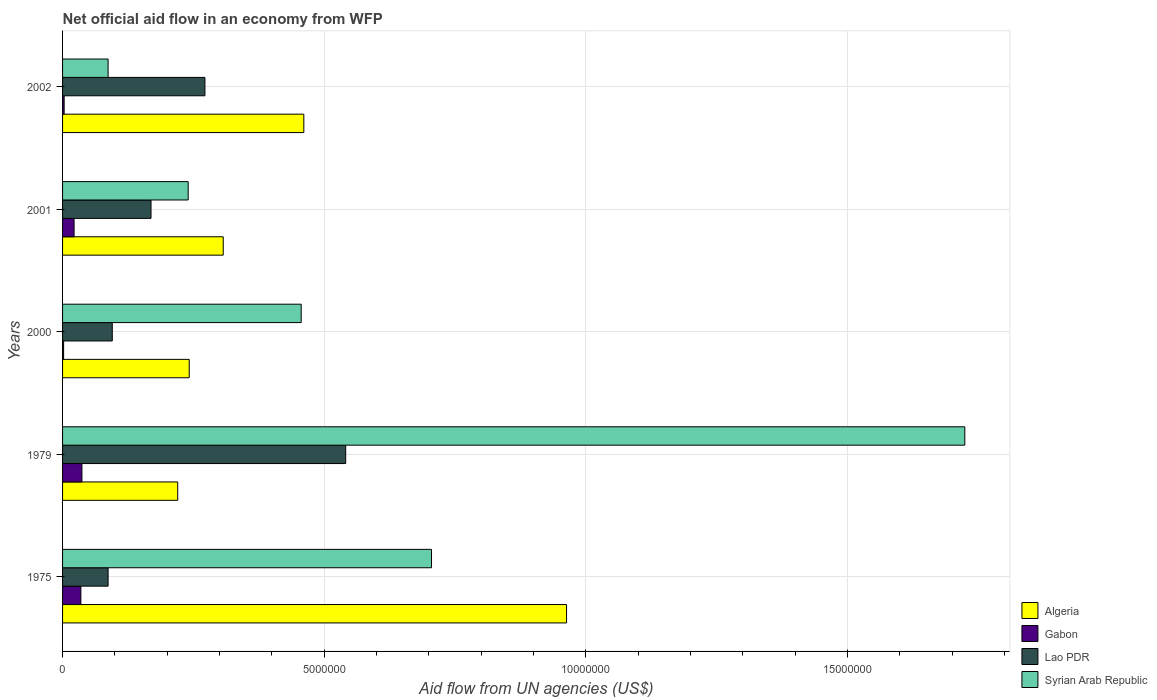How many different coloured bars are there?
Ensure brevity in your answer.  4. Are the number of bars on each tick of the Y-axis equal?
Give a very brief answer. Yes. What is the net official aid flow in Algeria in 1979?
Your answer should be very brief. 2.20e+06. Across all years, what is the maximum net official aid flow in Syrian Arab Republic?
Give a very brief answer. 1.72e+07. Across all years, what is the minimum net official aid flow in Algeria?
Make the answer very short. 2.20e+06. In which year was the net official aid flow in Algeria maximum?
Provide a short and direct response. 1975. In which year was the net official aid flow in Lao PDR minimum?
Your response must be concise. 1975. What is the total net official aid flow in Lao PDR in the graph?
Keep it short and to the point. 1.16e+07. What is the difference between the net official aid flow in Lao PDR in 1979 and that in 2002?
Give a very brief answer. 2.69e+06. What is the difference between the net official aid flow in Gabon in 1979 and the net official aid flow in Syrian Arab Republic in 2001?
Provide a short and direct response. -2.03e+06. What is the average net official aid flow in Algeria per year?
Your answer should be compact. 4.39e+06. In the year 2000, what is the difference between the net official aid flow in Syrian Arab Republic and net official aid flow in Lao PDR?
Give a very brief answer. 3.61e+06. In how many years, is the net official aid flow in Lao PDR greater than 11000000 US$?
Offer a very short reply. 0. What is the ratio of the net official aid flow in Gabon in 1979 to that in 2002?
Offer a very short reply. 12.33. What is the difference between the highest and the lowest net official aid flow in Gabon?
Provide a succinct answer. 3.50e+05. Is it the case that in every year, the sum of the net official aid flow in Gabon and net official aid flow in Syrian Arab Republic is greater than the sum of net official aid flow in Algeria and net official aid flow in Lao PDR?
Offer a very short reply. No. What does the 1st bar from the top in 2002 represents?
Offer a terse response. Syrian Arab Republic. What does the 1st bar from the bottom in 1979 represents?
Your response must be concise. Algeria. Are all the bars in the graph horizontal?
Your answer should be very brief. Yes. Does the graph contain any zero values?
Make the answer very short. No. Does the graph contain grids?
Provide a succinct answer. Yes. What is the title of the graph?
Your response must be concise. Net official aid flow in an economy from WFP. Does "Luxembourg" appear as one of the legend labels in the graph?
Provide a short and direct response. No. What is the label or title of the X-axis?
Make the answer very short. Aid flow from UN agencies (US$). What is the label or title of the Y-axis?
Give a very brief answer. Years. What is the Aid flow from UN agencies (US$) of Algeria in 1975?
Your response must be concise. 9.63e+06. What is the Aid flow from UN agencies (US$) in Gabon in 1975?
Offer a very short reply. 3.50e+05. What is the Aid flow from UN agencies (US$) in Lao PDR in 1975?
Make the answer very short. 8.70e+05. What is the Aid flow from UN agencies (US$) of Syrian Arab Republic in 1975?
Provide a succinct answer. 7.05e+06. What is the Aid flow from UN agencies (US$) of Algeria in 1979?
Offer a terse response. 2.20e+06. What is the Aid flow from UN agencies (US$) of Gabon in 1979?
Provide a short and direct response. 3.70e+05. What is the Aid flow from UN agencies (US$) of Lao PDR in 1979?
Offer a very short reply. 5.41e+06. What is the Aid flow from UN agencies (US$) in Syrian Arab Republic in 1979?
Keep it short and to the point. 1.72e+07. What is the Aid flow from UN agencies (US$) in Algeria in 2000?
Offer a very short reply. 2.42e+06. What is the Aid flow from UN agencies (US$) in Lao PDR in 2000?
Provide a succinct answer. 9.50e+05. What is the Aid flow from UN agencies (US$) of Syrian Arab Republic in 2000?
Offer a very short reply. 4.56e+06. What is the Aid flow from UN agencies (US$) in Algeria in 2001?
Provide a succinct answer. 3.07e+06. What is the Aid flow from UN agencies (US$) of Gabon in 2001?
Give a very brief answer. 2.20e+05. What is the Aid flow from UN agencies (US$) of Lao PDR in 2001?
Make the answer very short. 1.69e+06. What is the Aid flow from UN agencies (US$) of Syrian Arab Republic in 2001?
Make the answer very short. 2.40e+06. What is the Aid flow from UN agencies (US$) in Algeria in 2002?
Make the answer very short. 4.61e+06. What is the Aid flow from UN agencies (US$) in Gabon in 2002?
Your answer should be very brief. 3.00e+04. What is the Aid flow from UN agencies (US$) in Lao PDR in 2002?
Offer a terse response. 2.72e+06. What is the Aid flow from UN agencies (US$) of Syrian Arab Republic in 2002?
Your answer should be very brief. 8.70e+05. Across all years, what is the maximum Aid flow from UN agencies (US$) of Algeria?
Keep it short and to the point. 9.63e+06. Across all years, what is the maximum Aid flow from UN agencies (US$) in Lao PDR?
Ensure brevity in your answer.  5.41e+06. Across all years, what is the maximum Aid flow from UN agencies (US$) in Syrian Arab Republic?
Make the answer very short. 1.72e+07. Across all years, what is the minimum Aid flow from UN agencies (US$) in Algeria?
Offer a terse response. 2.20e+06. Across all years, what is the minimum Aid flow from UN agencies (US$) in Gabon?
Give a very brief answer. 2.00e+04. Across all years, what is the minimum Aid flow from UN agencies (US$) of Lao PDR?
Your answer should be very brief. 8.70e+05. Across all years, what is the minimum Aid flow from UN agencies (US$) in Syrian Arab Republic?
Your response must be concise. 8.70e+05. What is the total Aid flow from UN agencies (US$) of Algeria in the graph?
Provide a short and direct response. 2.19e+07. What is the total Aid flow from UN agencies (US$) of Gabon in the graph?
Provide a short and direct response. 9.90e+05. What is the total Aid flow from UN agencies (US$) of Lao PDR in the graph?
Keep it short and to the point. 1.16e+07. What is the total Aid flow from UN agencies (US$) in Syrian Arab Republic in the graph?
Your answer should be very brief. 3.21e+07. What is the difference between the Aid flow from UN agencies (US$) in Algeria in 1975 and that in 1979?
Provide a succinct answer. 7.43e+06. What is the difference between the Aid flow from UN agencies (US$) of Lao PDR in 1975 and that in 1979?
Offer a terse response. -4.54e+06. What is the difference between the Aid flow from UN agencies (US$) of Syrian Arab Republic in 1975 and that in 1979?
Provide a short and direct response. -1.02e+07. What is the difference between the Aid flow from UN agencies (US$) in Algeria in 1975 and that in 2000?
Your answer should be compact. 7.21e+06. What is the difference between the Aid flow from UN agencies (US$) in Gabon in 1975 and that in 2000?
Provide a succinct answer. 3.30e+05. What is the difference between the Aid flow from UN agencies (US$) in Lao PDR in 1975 and that in 2000?
Make the answer very short. -8.00e+04. What is the difference between the Aid flow from UN agencies (US$) in Syrian Arab Republic in 1975 and that in 2000?
Keep it short and to the point. 2.49e+06. What is the difference between the Aid flow from UN agencies (US$) in Algeria in 1975 and that in 2001?
Provide a short and direct response. 6.56e+06. What is the difference between the Aid flow from UN agencies (US$) of Lao PDR in 1975 and that in 2001?
Offer a very short reply. -8.20e+05. What is the difference between the Aid flow from UN agencies (US$) in Syrian Arab Republic in 1975 and that in 2001?
Give a very brief answer. 4.65e+06. What is the difference between the Aid flow from UN agencies (US$) of Algeria in 1975 and that in 2002?
Your answer should be very brief. 5.02e+06. What is the difference between the Aid flow from UN agencies (US$) of Lao PDR in 1975 and that in 2002?
Ensure brevity in your answer.  -1.85e+06. What is the difference between the Aid flow from UN agencies (US$) in Syrian Arab Republic in 1975 and that in 2002?
Make the answer very short. 6.18e+06. What is the difference between the Aid flow from UN agencies (US$) in Algeria in 1979 and that in 2000?
Ensure brevity in your answer.  -2.20e+05. What is the difference between the Aid flow from UN agencies (US$) in Lao PDR in 1979 and that in 2000?
Give a very brief answer. 4.46e+06. What is the difference between the Aid flow from UN agencies (US$) in Syrian Arab Republic in 1979 and that in 2000?
Provide a short and direct response. 1.27e+07. What is the difference between the Aid flow from UN agencies (US$) of Algeria in 1979 and that in 2001?
Your response must be concise. -8.70e+05. What is the difference between the Aid flow from UN agencies (US$) in Gabon in 1979 and that in 2001?
Provide a short and direct response. 1.50e+05. What is the difference between the Aid flow from UN agencies (US$) of Lao PDR in 1979 and that in 2001?
Keep it short and to the point. 3.72e+06. What is the difference between the Aid flow from UN agencies (US$) of Syrian Arab Republic in 1979 and that in 2001?
Provide a short and direct response. 1.48e+07. What is the difference between the Aid flow from UN agencies (US$) of Algeria in 1979 and that in 2002?
Ensure brevity in your answer.  -2.41e+06. What is the difference between the Aid flow from UN agencies (US$) in Lao PDR in 1979 and that in 2002?
Give a very brief answer. 2.69e+06. What is the difference between the Aid flow from UN agencies (US$) in Syrian Arab Republic in 1979 and that in 2002?
Give a very brief answer. 1.64e+07. What is the difference between the Aid flow from UN agencies (US$) in Algeria in 2000 and that in 2001?
Your answer should be very brief. -6.50e+05. What is the difference between the Aid flow from UN agencies (US$) of Gabon in 2000 and that in 2001?
Keep it short and to the point. -2.00e+05. What is the difference between the Aid flow from UN agencies (US$) in Lao PDR in 2000 and that in 2001?
Ensure brevity in your answer.  -7.40e+05. What is the difference between the Aid flow from UN agencies (US$) of Syrian Arab Republic in 2000 and that in 2001?
Your answer should be very brief. 2.16e+06. What is the difference between the Aid flow from UN agencies (US$) in Algeria in 2000 and that in 2002?
Make the answer very short. -2.19e+06. What is the difference between the Aid flow from UN agencies (US$) of Gabon in 2000 and that in 2002?
Your response must be concise. -10000. What is the difference between the Aid flow from UN agencies (US$) of Lao PDR in 2000 and that in 2002?
Your answer should be very brief. -1.77e+06. What is the difference between the Aid flow from UN agencies (US$) of Syrian Arab Republic in 2000 and that in 2002?
Offer a terse response. 3.69e+06. What is the difference between the Aid flow from UN agencies (US$) in Algeria in 2001 and that in 2002?
Give a very brief answer. -1.54e+06. What is the difference between the Aid flow from UN agencies (US$) in Lao PDR in 2001 and that in 2002?
Your answer should be compact. -1.03e+06. What is the difference between the Aid flow from UN agencies (US$) of Syrian Arab Republic in 2001 and that in 2002?
Offer a terse response. 1.53e+06. What is the difference between the Aid flow from UN agencies (US$) of Algeria in 1975 and the Aid flow from UN agencies (US$) of Gabon in 1979?
Your answer should be compact. 9.26e+06. What is the difference between the Aid flow from UN agencies (US$) of Algeria in 1975 and the Aid flow from UN agencies (US$) of Lao PDR in 1979?
Your response must be concise. 4.22e+06. What is the difference between the Aid flow from UN agencies (US$) of Algeria in 1975 and the Aid flow from UN agencies (US$) of Syrian Arab Republic in 1979?
Your answer should be compact. -7.61e+06. What is the difference between the Aid flow from UN agencies (US$) in Gabon in 1975 and the Aid flow from UN agencies (US$) in Lao PDR in 1979?
Keep it short and to the point. -5.06e+06. What is the difference between the Aid flow from UN agencies (US$) in Gabon in 1975 and the Aid flow from UN agencies (US$) in Syrian Arab Republic in 1979?
Your answer should be compact. -1.69e+07. What is the difference between the Aid flow from UN agencies (US$) of Lao PDR in 1975 and the Aid flow from UN agencies (US$) of Syrian Arab Republic in 1979?
Your answer should be very brief. -1.64e+07. What is the difference between the Aid flow from UN agencies (US$) of Algeria in 1975 and the Aid flow from UN agencies (US$) of Gabon in 2000?
Your answer should be compact. 9.61e+06. What is the difference between the Aid flow from UN agencies (US$) of Algeria in 1975 and the Aid flow from UN agencies (US$) of Lao PDR in 2000?
Your answer should be very brief. 8.68e+06. What is the difference between the Aid flow from UN agencies (US$) of Algeria in 1975 and the Aid flow from UN agencies (US$) of Syrian Arab Republic in 2000?
Give a very brief answer. 5.07e+06. What is the difference between the Aid flow from UN agencies (US$) in Gabon in 1975 and the Aid flow from UN agencies (US$) in Lao PDR in 2000?
Offer a terse response. -6.00e+05. What is the difference between the Aid flow from UN agencies (US$) of Gabon in 1975 and the Aid flow from UN agencies (US$) of Syrian Arab Republic in 2000?
Offer a terse response. -4.21e+06. What is the difference between the Aid flow from UN agencies (US$) of Lao PDR in 1975 and the Aid flow from UN agencies (US$) of Syrian Arab Republic in 2000?
Offer a terse response. -3.69e+06. What is the difference between the Aid flow from UN agencies (US$) of Algeria in 1975 and the Aid flow from UN agencies (US$) of Gabon in 2001?
Your answer should be very brief. 9.41e+06. What is the difference between the Aid flow from UN agencies (US$) of Algeria in 1975 and the Aid flow from UN agencies (US$) of Lao PDR in 2001?
Offer a terse response. 7.94e+06. What is the difference between the Aid flow from UN agencies (US$) in Algeria in 1975 and the Aid flow from UN agencies (US$) in Syrian Arab Republic in 2001?
Give a very brief answer. 7.23e+06. What is the difference between the Aid flow from UN agencies (US$) in Gabon in 1975 and the Aid flow from UN agencies (US$) in Lao PDR in 2001?
Offer a very short reply. -1.34e+06. What is the difference between the Aid flow from UN agencies (US$) in Gabon in 1975 and the Aid flow from UN agencies (US$) in Syrian Arab Republic in 2001?
Provide a succinct answer. -2.05e+06. What is the difference between the Aid flow from UN agencies (US$) of Lao PDR in 1975 and the Aid flow from UN agencies (US$) of Syrian Arab Republic in 2001?
Provide a succinct answer. -1.53e+06. What is the difference between the Aid flow from UN agencies (US$) in Algeria in 1975 and the Aid flow from UN agencies (US$) in Gabon in 2002?
Your response must be concise. 9.60e+06. What is the difference between the Aid flow from UN agencies (US$) in Algeria in 1975 and the Aid flow from UN agencies (US$) in Lao PDR in 2002?
Make the answer very short. 6.91e+06. What is the difference between the Aid flow from UN agencies (US$) of Algeria in 1975 and the Aid flow from UN agencies (US$) of Syrian Arab Republic in 2002?
Provide a succinct answer. 8.76e+06. What is the difference between the Aid flow from UN agencies (US$) in Gabon in 1975 and the Aid flow from UN agencies (US$) in Lao PDR in 2002?
Your answer should be very brief. -2.37e+06. What is the difference between the Aid flow from UN agencies (US$) of Gabon in 1975 and the Aid flow from UN agencies (US$) of Syrian Arab Republic in 2002?
Your response must be concise. -5.20e+05. What is the difference between the Aid flow from UN agencies (US$) of Algeria in 1979 and the Aid flow from UN agencies (US$) of Gabon in 2000?
Keep it short and to the point. 2.18e+06. What is the difference between the Aid flow from UN agencies (US$) of Algeria in 1979 and the Aid flow from UN agencies (US$) of Lao PDR in 2000?
Your answer should be compact. 1.25e+06. What is the difference between the Aid flow from UN agencies (US$) of Algeria in 1979 and the Aid flow from UN agencies (US$) of Syrian Arab Republic in 2000?
Make the answer very short. -2.36e+06. What is the difference between the Aid flow from UN agencies (US$) in Gabon in 1979 and the Aid flow from UN agencies (US$) in Lao PDR in 2000?
Provide a succinct answer. -5.80e+05. What is the difference between the Aid flow from UN agencies (US$) in Gabon in 1979 and the Aid flow from UN agencies (US$) in Syrian Arab Republic in 2000?
Offer a very short reply. -4.19e+06. What is the difference between the Aid flow from UN agencies (US$) in Lao PDR in 1979 and the Aid flow from UN agencies (US$) in Syrian Arab Republic in 2000?
Give a very brief answer. 8.50e+05. What is the difference between the Aid flow from UN agencies (US$) of Algeria in 1979 and the Aid flow from UN agencies (US$) of Gabon in 2001?
Provide a short and direct response. 1.98e+06. What is the difference between the Aid flow from UN agencies (US$) of Algeria in 1979 and the Aid flow from UN agencies (US$) of Lao PDR in 2001?
Offer a very short reply. 5.10e+05. What is the difference between the Aid flow from UN agencies (US$) of Gabon in 1979 and the Aid flow from UN agencies (US$) of Lao PDR in 2001?
Offer a very short reply. -1.32e+06. What is the difference between the Aid flow from UN agencies (US$) of Gabon in 1979 and the Aid flow from UN agencies (US$) of Syrian Arab Republic in 2001?
Offer a very short reply. -2.03e+06. What is the difference between the Aid flow from UN agencies (US$) in Lao PDR in 1979 and the Aid flow from UN agencies (US$) in Syrian Arab Republic in 2001?
Offer a terse response. 3.01e+06. What is the difference between the Aid flow from UN agencies (US$) of Algeria in 1979 and the Aid flow from UN agencies (US$) of Gabon in 2002?
Offer a very short reply. 2.17e+06. What is the difference between the Aid flow from UN agencies (US$) in Algeria in 1979 and the Aid flow from UN agencies (US$) in Lao PDR in 2002?
Give a very brief answer. -5.20e+05. What is the difference between the Aid flow from UN agencies (US$) in Algeria in 1979 and the Aid flow from UN agencies (US$) in Syrian Arab Republic in 2002?
Ensure brevity in your answer.  1.33e+06. What is the difference between the Aid flow from UN agencies (US$) in Gabon in 1979 and the Aid flow from UN agencies (US$) in Lao PDR in 2002?
Your answer should be very brief. -2.35e+06. What is the difference between the Aid flow from UN agencies (US$) in Gabon in 1979 and the Aid flow from UN agencies (US$) in Syrian Arab Republic in 2002?
Keep it short and to the point. -5.00e+05. What is the difference between the Aid flow from UN agencies (US$) in Lao PDR in 1979 and the Aid flow from UN agencies (US$) in Syrian Arab Republic in 2002?
Your answer should be very brief. 4.54e+06. What is the difference between the Aid flow from UN agencies (US$) of Algeria in 2000 and the Aid flow from UN agencies (US$) of Gabon in 2001?
Give a very brief answer. 2.20e+06. What is the difference between the Aid flow from UN agencies (US$) in Algeria in 2000 and the Aid flow from UN agencies (US$) in Lao PDR in 2001?
Ensure brevity in your answer.  7.30e+05. What is the difference between the Aid flow from UN agencies (US$) in Algeria in 2000 and the Aid flow from UN agencies (US$) in Syrian Arab Republic in 2001?
Make the answer very short. 2.00e+04. What is the difference between the Aid flow from UN agencies (US$) of Gabon in 2000 and the Aid flow from UN agencies (US$) of Lao PDR in 2001?
Make the answer very short. -1.67e+06. What is the difference between the Aid flow from UN agencies (US$) in Gabon in 2000 and the Aid flow from UN agencies (US$) in Syrian Arab Republic in 2001?
Offer a very short reply. -2.38e+06. What is the difference between the Aid flow from UN agencies (US$) in Lao PDR in 2000 and the Aid flow from UN agencies (US$) in Syrian Arab Republic in 2001?
Provide a short and direct response. -1.45e+06. What is the difference between the Aid flow from UN agencies (US$) of Algeria in 2000 and the Aid flow from UN agencies (US$) of Gabon in 2002?
Offer a very short reply. 2.39e+06. What is the difference between the Aid flow from UN agencies (US$) of Algeria in 2000 and the Aid flow from UN agencies (US$) of Syrian Arab Republic in 2002?
Make the answer very short. 1.55e+06. What is the difference between the Aid flow from UN agencies (US$) in Gabon in 2000 and the Aid flow from UN agencies (US$) in Lao PDR in 2002?
Offer a very short reply. -2.70e+06. What is the difference between the Aid flow from UN agencies (US$) of Gabon in 2000 and the Aid flow from UN agencies (US$) of Syrian Arab Republic in 2002?
Your answer should be very brief. -8.50e+05. What is the difference between the Aid flow from UN agencies (US$) in Lao PDR in 2000 and the Aid flow from UN agencies (US$) in Syrian Arab Republic in 2002?
Make the answer very short. 8.00e+04. What is the difference between the Aid flow from UN agencies (US$) in Algeria in 2001 and the Aid flow from UN agencies (US$) in Gabon in 2002?
Provide a succinct answer. 3.04e+06. What is the difference between the Aid flow from UN agencies (US$) of Algeria in 2001 and the Aid flow from UN agencies (US$) of Syrian Arab Republic in 2002?
Your answer should be very brief. 2.20e+06. What is the difference between the Aid flow from UN agencies (US$) in Gabon in 2001 and the Aid flow from UN agencies (US$) in Lao PDR in 2002?
Offer a terse response. -2.50e+06. What is the difference between the Aid flow from UN agencies (US$) of Gabon in 2001 and the Aid flow from UN agencies (US$) of Syrian Arab Republic in 2002?
Your answer should be very brief. -6.50e+05. What is the difference between the Aid flow from UN agencies (US$) in Lao PDR in 2001 and the Aid flow from UN agencies (US$) in Syrian Arab Republic in 2002?
Ensure brevity in your answer.  8.20e+05. What is the average Aid flow from UN agencies (US$) in Algeria per year?
Keep it short and to the point. 4.39e+06. What is the average Aid flow from UN agencies (US$) of Gabon per year?
Your response must be concise. 1.98e+05. What is the average Aid flow from UN agencies (US$) of Lao PDR per year?
Keep it short and to the point. 2.33e+06. What is the average Aid flow from UN agencies (US$) of Syrian Arab Republic per year?
Give a very brief answer. 6.42e+06. In the year 1975, what is the difference between the Aid flow from UN agencies (US$) of Algeria and Aid flow from UN agencies (US$) of Gabon?
Offer a terse response. 9.28e+06. In the year 1975, what is the difference between the Aid flow from UN agencies (US$) of Algeria and Aid flow from UN agencies (US$) of Lao PDR?
Your response must be concise. 8.76e+06. In the year 1975, what is the difference between the Aid flow from UN agencies (US$) of Algeria and Aid flow from UN agencies (US$) of Syrian Arab Republic?
Make the answer very short. 2.58e+06. In the year 1975, what is the difference between the Aid flow from UN agencies (US$) in Gabon and Aid flow from UN agencies (US$) in Lao PDR?
Provide a short and direct response. -5.20e+05. In the year 1975, what is the difference between the Aid flow from UN agencies (US$) of Gabon and Aid flow from UN agencies (US$) of Syrian Arab Republic?
Offer a terse response. -6.70e+06. In the year 1975, what is the difference between the Aid flow from UN agencies (US$) of Lao PDR and Aid flow from UN agencies (US$) of Syrian Arab Republic?
Your response must be concise. -6.18e+06. In the year 1979, what is the difference between the Aid flow from UN agencies (US$) of Algeria and Aid flow from UN agencies (US$) of Gabon?
Provide a short and direct response. 1.83e+06. In the year 1979, what is the difference between the Aid flow from UN agencies (US$) in Algeria and Aid flow from UN agencies (US$) in Lao PDR?
Provide a short and direct response. -3.21e+06. In the year 1979, what is the difference between the Aid flow from UN agencies (US$) of Algeria and Aid flow from UN agencies (US$) of Syrian Arab Republic?
Keep it short and to the point. -1.50e+07. In the year 1979, what is the difference between the Aid flow from UN agencies (US$) in Gabon and Aid flow from UN agencies (US$) in Lao PDR?
Your response must be concise. -5.04e+06. In the year 1979, what is the difference between the Aid flow from UN agencies (US$) in Gabon and Aid flow from UN agencies (US$) in Syrian Arab Republic?
Your answer should be compact. -1.69e+07. In the year 1979, what is the difference between the Aid flow from UN agencies (US$) of Lao PDR and Aid flow from UN agencies (US$) of Syrian Arab Republic?
Offer a terse response. -1.18e+07. In the year 2000, what is the difference between the Aid flow from UN agencies (US$) in Algeria and Aid flow from UN agencies (US$) in Gabon?
Provide a succinct answer. 2.40e+06. In the year 2000, what is the difference between the Aid flow from UN agencies (US$) of Algeria and Aid flow from UN agencies (US$) of Lao PDR?
Give a very brief answer. 1.47e+06. In the year 2000, what is the difference between the Aid flow from UN agencies (US$) in Algeria and Aid flow from UN agencies (US$) in Syrian Arab Republic?
Your response must be concise. -2.14e+06. In the year 2000, what is the difference between the Aid flow from UN agencies (US$) of Gabon and Aid flow from UN agencies (US$) of Lao PDR?
Give a very brief answer. -9.30e+05. In the year 2000, what is the difference between the Aid flow from UN agencies (US$) in Gabon and Aid flow from UN agencies (US$) in Syrian Arab Republic?
Offer a terse response. -4.54e+06. In the year 2000, what is the difference between the Aid flow from UN agencies (US$) in Lao PDR and Aid flow from UN agencies (US$) in Syrian Arab Republic?
Provide a short and direct response. -3.61e+06. In the year 2001, what is the difference between the Aid flow from UN agencies (US$) in Algeria and Aid flow from UN agencies (US$) in Gabon?
Keep it short and to the point. 2.85e+06. In the year 2001, what is the difference between the Aid flow from UN agencies (US$) of Algeria and Aid flow from UN agencies (US$) of Lao PDR?
Ensure brevity in your answer.  1.38e+06. In the year 2001, what is the difference between the Aid flow from UN agencies (US$) in Algeria and Aid flow from UN agencies (US$) in Syrian Arab Republic?
Provide a short and direct response. 6.70e+05. In the year 2001, what is the difference between the Aid flow from UN agencies (US$) of Gabon and Aid flow from UN agencies (US$) of Lao PDR?
Give a very brief answer. -1.47e+06. In the year 2001, what is the difference between the Aid flow from UN agencies (US$) in Gabon and Aid flow from UN agencies (US$) in Syrian Arab Republic?
Ensure brevity in your answer.  -2.18e+06. In the year 2001, what is the difference between the Aid flow from UN agencies (US$) in Lao PDR and Aid flow from UN agencies (US$) in Syrian Arab Republic?
Offer a terse response. -7.10e+05. In the year 2002, what is the difference between the Aid flow from UN agencies (US$) in Algeria and Aid flow from UN agencies (US$) in Gabon?
Provide a short and direct response. 4.58e+06. In the year 2002, what is the difference between the Aid flow from UN agencies (US$) of Algeria and Aid flow from UN agencies (US$) of Lao PDR?
Provide a short and direct response. 1.89e+06. In the year 2002, what is the difference between the Aid flow from UN agencies (US$) in Algeria and Aid flow from UN agencies (US$) in Syrian Arab Republic?
Provide a succinct answer. 3.74e+06. In the year 2002, what is the difference between the Aid flow from UN agencies (US$) of Gabon and Aid flow from UN agencies (US$) of Lao PDR?
Your answer should be compact. -2.69e+06. In the year 2002, what is the difference between the Aid flow from UN agencies (US$) of Gabon and Aid flow from UN agencies (US$) of Syrian Arab Republic?
Provide a succinct answer. -8.40e+05. In the year 2002, what is the difference between the Aid flow from UN agencies (US$) of Lao PDR and Aid flow from UN agencies (US$) of Syrian Arab Republic?
Offer a terse response. 1.85e+06. What is the ratio of the Aid flow from UN agencies (US$) of Algeria in 1975 to that in 1979?
Your answer should be very brief. 4.38. What is the ratio of the Aid flow from UN agencies (US$) in Gabon in 1975 to that in 1979?
Offer a very short reply. 0.95. What is the ratio of the Aid flow from UN agencies (US$) in Lao PDR in 1975 to that in 1979?
Provide a short and direct response. 0.16. What is the ratio of the Aid flow from UN agencies (US$) of Syrian Arab Republic in 1975 to that in 1979?
Make the answer very short. 0.41. What is the ratio of the Aid flow from UN agencies (US$) in Algeria in 1975 to that in 2000?
Make the answer very short. 3.98. What is the ratio of the Aid flow from UN agencies (US$) of Gabon in 1975 to that in 2000?
Offer a very short reply. 17.5. What is the ratio of the Aid flow from UN agencies (US$) in Lao PDR in 1975 to that in 2000?
Offer a very short reply. 0.92. What is the ratio of the Aid flow from UN agencies (US$) in Syrian Arab Republic in 1975 to that in 2000?
Your answer should be very brief. 1.55. What is the ratio of the Aid flow from UN agencies (US$) of Algeria in 1975 to that in 2001?
Provide a short and direct response. 3.14. What is the ratio of the Aid flow from UN agencies (US$) in Gabon in 1975 to that in 2001?
Your answer should be compact. 1.59. What is the ratio of the Aid flow from UN agencies (US$) of Lao PDR in 1975 to that in 2001?
Offer a very short reply. 0.51. What is the ratio of the Aid flow from UN agencies (US$) in Syrian Arab Republic in 1975 to that in 2001?
Offer a terse response. 2.94. What is the ratio of the Aid flow from UN agencies (US$) of Algeria in 1975 to that in 2002?
Ensure brevity in your answer.  2.09. What is the ratio of the Aid flow from UN agencies (US$) in Gabon in 1975 to that in 2002?
Offer a terse response. 11.67. What is the ratio of the Aid flow from UN agencies (US$) of Lao PDR in 1975 to that in 2002?
Provide a short and direct response. 0.32. What is the ratio of the Aid flow from UN agencies (US$) in Syrian Arab Republic in 1975 to that in 2002?
Your answer should be compact. 8.1. What is the ratio of the Aid flow from UN agencies (US$) in Algeria in 1979 to that in 2000?
Offer a terse response. 0.91. What is the ratio of the Aid flow from UN agencies (US$) in Lao PDR in 1979 to that in 2000?
Make the answer very short. 5.69. What is the ratio of the Aid flow from UN agencies (US$) of Syrian Arab Republic in 1979 to that in 2000?
Your response must be concise. 3.78. What is the ratio of the Aid flow from UN agencies (US$) of Algeria in 1979 to that in 2001?
Your answer should be very brief. 0.72. What is the ratio of the Aid flow from UN agencies (US$) in Gabon in 1979 to that in 2001?
Offer a very short reply. 1.68. What is the ratio of the Aid flow from UN agencies (US$) of Lao PDR in 1979 to that in 2001?
Offer a very short reply. 3.2. What is the ratio of the Aid flow from UN agencies (US$) in Syrian Arab Republic in 1979 to that in 2001?
Your response must be concise. 7.18. What is the ratio of the Aid flow from UN agencies (US$) of Algeria in 1979 to that in 2002?
Keep it short and to the point. 0.48. What is the ratio of the Aid flow from UN agencies (US$) of Gabon in 1979 to that in 2002?
Your response must be concise. 12.33. What is the ratio of the Aid flow from UN agencies (US$) of Lao PDR in 1979 to that in 2002?
Provide a succinct answer. 1.99. What is the ratio of the Aid flow from UN agencies (US$) of Syrian Arab Republic in 1979 to that in 2002?
Your answer should be compact. 19.82. What is the ratio of the Aid flow from UN agencies (US$) in Algeria in 2000 to that in 2001?
Ensure brevity in your answer.  0.79. What is the ratio of the Aid flow from UN agencies (US$) in Gabon in 2000 to that in 2001?
Provide a short and direct response. 0.09. What is the ratio of the Aid flow from UN agencies (US$) of Lao PDR in 2000 to that in 2001?
Your response must be concise. 0.56. What is the ratio of the Aid flow from UN agencies (US$) in Syrian Arab Republic in 2000 to that in 2001?
Ensure brevity in your answer.  1.9. What is the ratio of the Aid flow from UN agencies (US$) in Algeria in 2000 to that in 2002?
Your response must be concise. 0.52. What is the ratio of the Aid flow from UN agencies (US$) in Lao PDR in 2000 to that in 2002?
Offer a very short reply. 0.35. What is the ratio of the Aid flow from UN agencies (US$) of Syrian Arab Republic in 2000 to that in 2002?
Give a very brief answer. 5.24. What is the ratio of the Aid flow from UN agencies (US$) of Algeria in 2001 to that in 2002?
Ensure brevity in your answer.  0.67. What is the ratio of the Aid flow from UN agencies (US$) of Gabon in 2001 to that in 2002?
Offer a terse response. 7.33. What is the ratio of the Aid flow from UN agencies (US$) of Lao PDR in 2001 to that in 2002?
Offer a very short reply. 0.62. What is the ratio of the Aid flow from UN agencies (US$) of Syrian Arab Republic in 2001 to that in 2002?
Offer a very short reply. 2.76. What is the difference between the highest and the second highest Aid flow from UN agencies (US$) in Algeria?
Offer a terse response. 5.02e+06. What is the difference between the highest and the second highest Aid flow from UN agencies (US$) in Gabon?
Keep it short and to the point. 2.00e+04. What is the difference between the highest and the second highest Aid flow from UN agencies (US$) in Lao PDR?
Your answer should be very brief. 2.69e+06. What is the difference between the highest and the second highest Aid flow from UN agencies (US$) in Syrian Arab Republic?
Your answer should be very brief. 1.02e+07. What is the difference between the highest and the lowest Aid flow from UN agencies (US$) in Algeria?
Provide a short and direct response. 7.43e+06. What is the difference between the highest and the lowest Aid flow from UN agencies (US$) of Gabon?
Give a very brief answer. 3.50e+05. What is the difference between the highest and the lowest Aid flow from UN agencies (US$) in Lao PDR?
Your response must be concise. 4.54e+06. What is the difference between the highest and the lowest Aid flow from UN agencies (US$) of Syrian Arab Republic?
Your response must be concise. 1.64e+07. 